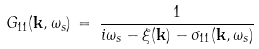<formula> <loc_0><loc_0><loc_500><loc_500>G _ { 1 1 } ( { \mathbf k } , \omega _ { s } ) \, = \, \frac { 1 } { i \omega _ { s } - \xi ( { \mathbf k } ) - \sigma _ { 1 1 } ( { \mathbf k } , \omega _ { s } ) }</formula> 